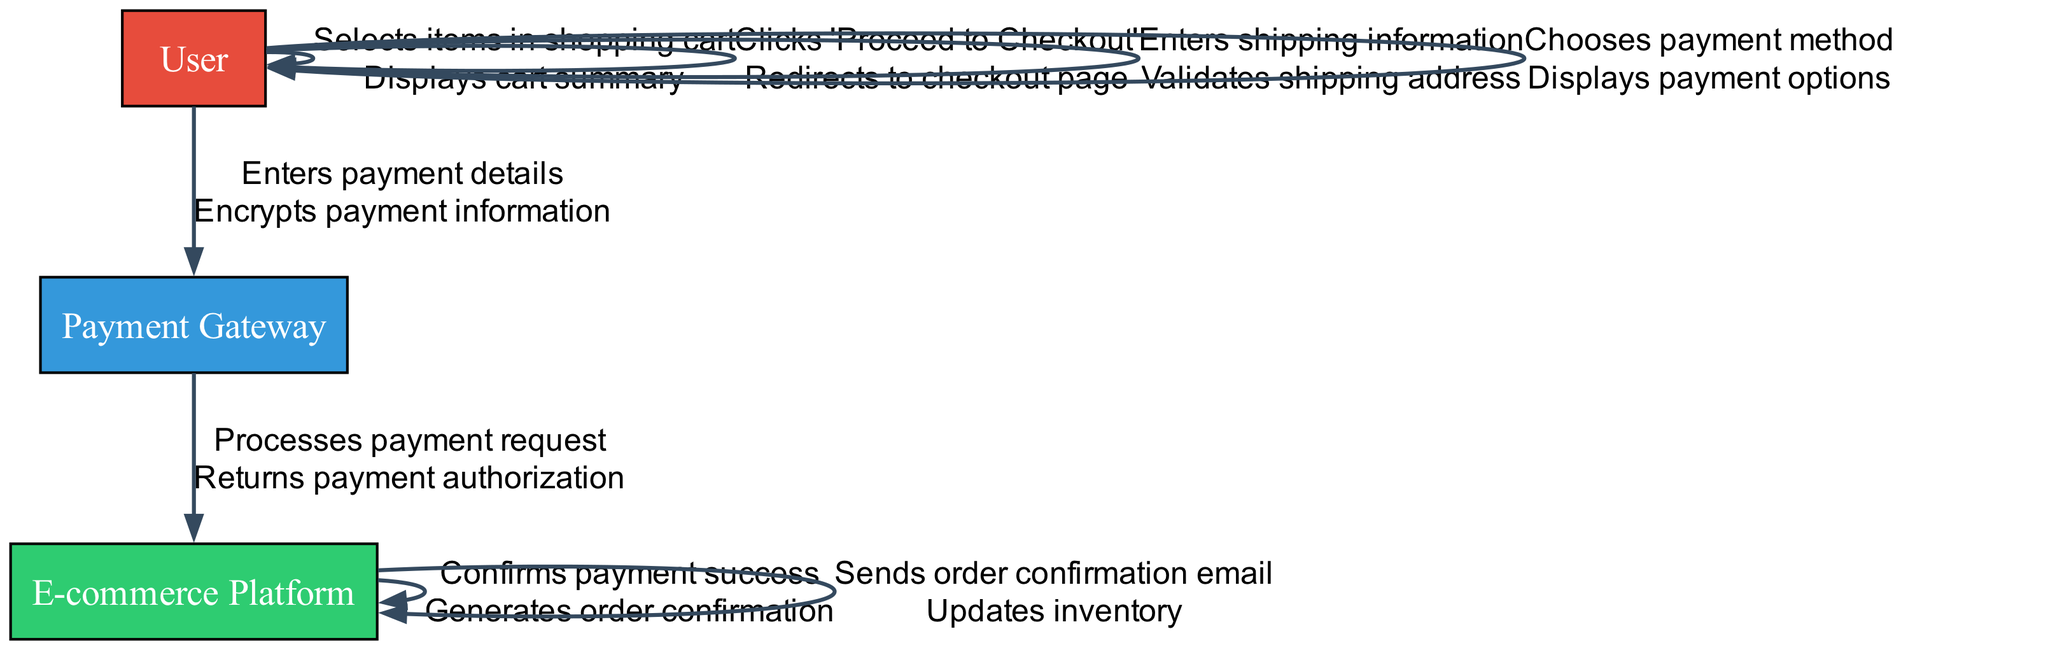What user action initiates the checkout process? The user action that starts the checkout process is "Clicks 'Proceed to Checkout'." This step is clearly depicted in the sequence diagram as the action directly leading to the redirection of the user to the checkout page.
Answer: Clicks 'Proceed to Checkout' How many unique system responses are displayed in the diagram? By analyzing the diagram elements, we identify six unique system responses: displays cart summary, redirects to checkout page, validates shipping address, displays payment options, encrypts payment information, returns payment authorization, generates order confirmation, sends order confirmation email, and updates inventory. Counting these distinct responses gives us a total of seven.
Answer: Seven What is the last action taken by the E-commerce Platform? The last action taken by the E-commerce Platform in the diagram is "Sends order confirmation email." This is indicated as the final action listed under the E-commerce Platform, following the order confirmation generation.
Answer: Sends order confirmation email Which user action leads to the payment option display? The user action that leads to the display of payment options is "Chooses payment method." This action is followed by the system response that shows the available payment options to the user, establishing a direct connection and flow.
Answer: Chooses payment method What action occurs immediately after the user enters payment details? Immediately after the user enters payment details, the system response is "Encrypts payment information." The diagram indicates a connected flow where entering payment details culminates in the encryption of that information to ensure security.
Answer: Encrypts payment information What signifies the success of the payment processing? The success of the payment processing is signified by the action "Confirms payment success." This action is crucial as it represents verification of a successful payment being processed, leading to the next steps in the order confirmation.
Answer: Confirms payment success How many actions does the User perform before the Payment Gateway processes the payment? The User performs four actions prior to the Payment Gateway processing the payment: selects items in the shopping cart, clicks 'Proceed to Checkout', enters shipping information, and chooses payment method. Counting these actions provides the total.
Answer: Four 